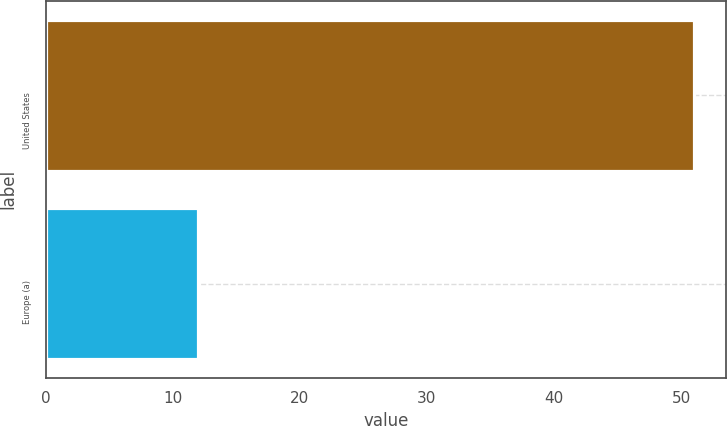<chart> <loc_0><loc_0><loc_500><loc_500><bar_chart><fcel>United States<fcel>Europe (a)<nl><fcel>51<fcel>12<nl></chart> 